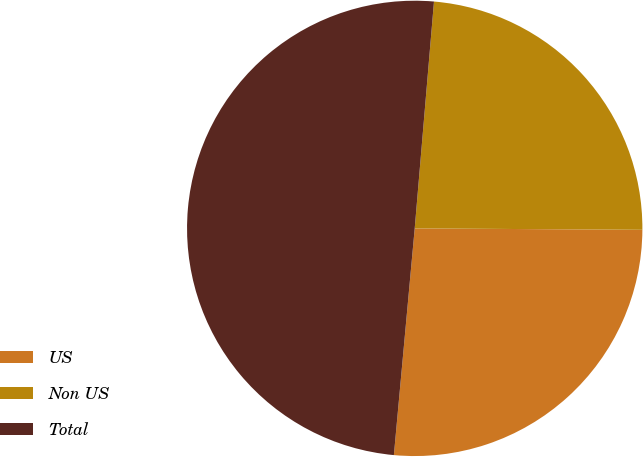<chart> <loc_0><loc_0><loc_500><loc_500><pie_chart><fcel>US<fcel>Non US<fcel>Total<nl><fcel>26.36%<fcel>23.75%<fcel>49.89%<nl></chart> 